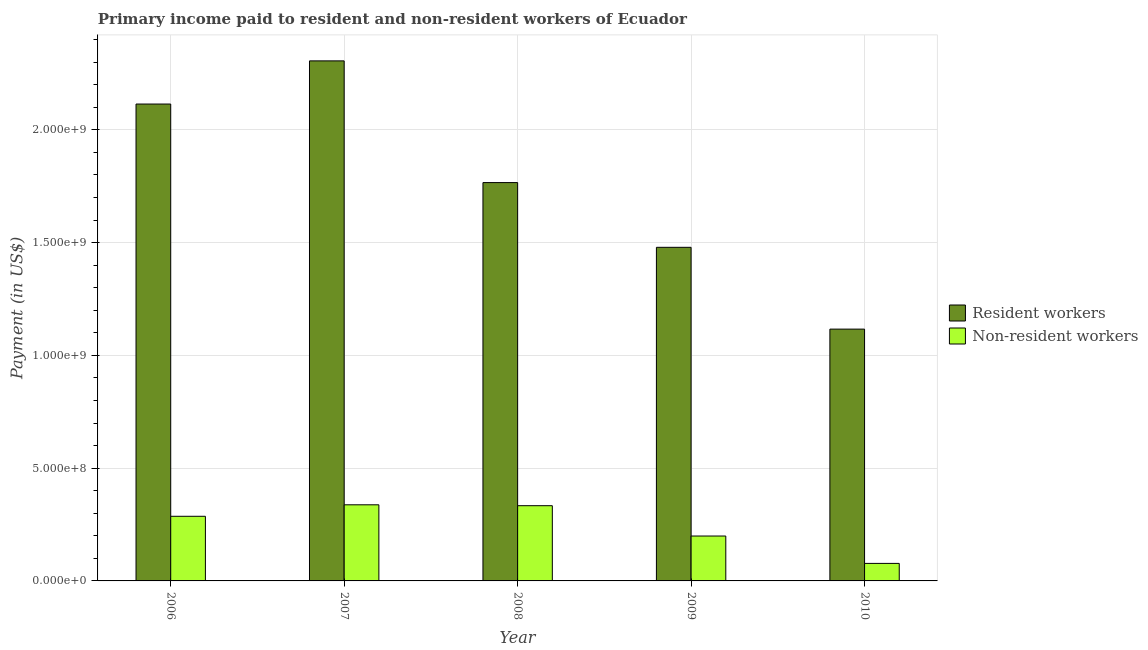How many bars are there on the 5th tick from the right?
Give a very brief answer. 2. What is the label of the 4th group of bars from the left?
Provide a short and direct response. 2009. In how many cases, is the number of bars for a given year not equal to the number of legend labels?
Give a very brief answer. 0. What is the payment made to non-resident workers in 2007?
Offer a very short reply. 3.37e+08. Across all years, what is the maximum payment made to non-resident workers?
Provide a short and direct response. 3.37e+08. Across all years, what is the minimum payment made to non-resident workers?
Keep it short and to the point. 7.77e+07. In which year was the payment made to non-resident workers maximum?
Keep it short and to the point. 2007. What is the total payment made to resident workers in the graph?
Give a very brief answer. 8.78e+09. What is the difference between the payment made to non-resident workers in 2008 and that in 2010?
Give a very brief answer. 2.56e+08. What is the difference between the payment made to resident workers in 2006 and the payment made to non-resident workers in 2007?
Ensure brevity in your answer.  -1.91e+08. What is the average payment made to non-resident workers per year?
Provide a succinct answer. 2.47e+08. In the year 2010, what is the difference between the payment made to resident workers and payment made to non-resident workers?
Your answer should be very brief. 0. In how many years, is the payment made to non-resident workers greater than 600000000 US$?
Keep it short and to the point. 0. What is the ratio of the payment made to non-resident workers in 2006 to that in 2010?
Your response must be concise. 3.69. What is the difference between the highest and the second highest payment made to non-resident workers?
Offer a terse response. 3.93e+06. What is the difference between the highest and the lowest payment made to non-resident workers?
Offer a terse response. 2.60e+08. In how many years, is the payment made to non-resident workers greater than the average payment made to non-resident workers taken over all years?
Offer a terse response. 3. What does the 2nd bar from the left in 2010 represents?
Give a very brief answer. Non-resident workers. What does the 1st bar from the right in 2008 represents?
Provide a succinct answer. Non-resident workers. How many bars are there?
Keep it short and to the point. 10. How many years are there in the graph?
Offer a terse response. 5. What is the difference between two consecutive major ticks on the Y-axis?
Offer a terse response. 5.00e+08. Does the graph contain any zero values?
Ensure brevity in your answer.  No. How are the legend labels stacked?
Provide a short and direct response. Vertical. What is the title of the graph?
Your response must be concise. Primary income paid to resident and non-resident workers of Ecuador. What is the label or title of the X-axis?
Make the answer very short. Year. What is the label or title of the Y-axis?
Provide a succinct answer. Payment (in US$). What is the Payment (in US$) of Resident workers in 2006?
Your answer should be compact. 2.11e+09. What is the Payment (in US$) in Non-resident workers in 2006?
Make the answer very short. 2.87e+08. What is the Payment (in US$) in Resident workers in 2007?
Provide a succinct answer. 2.31e+09. What is the Payment (in US$) in Non-resident workers in 2007?
Your answer should be compact. 3.37e+08. What is the Payment (in US$) in Resident workers in 2008?
Offer a terse response. 1.77e+09. What is the Payment (in US$) in Non-resident workers in 2008?
Your answer should be compact. 3.34e+08. What is the Payment (in US$) of Resident workers in 2009?
Offer a terse response. 1.48e+09. What is the Payment (in US$) of Non-resident workers in 2009?
Keep it short and to the point. 1.99e+08. What is the Payment (in US$) of Resident workers in 2010?
Ensure brevity in your answer.  1.12e+09. What is the Payment (in US$) in Non-resident workers in 2010?
Your answer should be very brief. 7.77e+07. Across all years, what is the maximum Payment (in US$) in Resident workers?
Provide a succinct answer. 2.31e+09. Across all years, what is the maximum Payment (in US$) of Non-resident workers?
Your answer should be compact. 3.37e+08. Across all years, what is the minimum Payment (in US$) in Resident workers?
Your response must be concise. 1.12e+09. Across all years, what is the minimum Payment (in US$) of Non-resident workers?
Your response must be concise. 7.77e+07. What is the total Payment (in US$) in Resident workers in the graph?
Provide a succinct answer. 8.78e+09. What is the total Payment (in US$) of Non-resident workers in the graph?
Provide a short and direct response. 1.23e+09. What is the difference between the Payment (in US$) of Resident workers in 2006 and that in 2007?
Give a very brief answer. -1.91e+08. What is the difference between the Payment (in US$) of Non-resident workers in 2006 and that in 2007?
Your answer should be very brief. -5.09e+07. What is the difference between the Payment (in US$) in Resident workers in 2006 and that in 2008?
Provide a short and direct response. 3.48e+08. What is the difference between the Payment (in US$) of Non-resident workers in 2006 and that in 2008?
Your answer should be compact. -4.69e+07. What is the difference between the Payment (in US$) of Resident workers in 2006 and that in 2009?
Offer a very short reply. 6.35e+08. What is the difference between the Payment (in US$) of Non-resident workers in 2006 and that in 2009?
Make the answer very short. 8.75e+07. What is the difference between the Payment (in US$) of Resident workers in 2006 and that in 2010?
Your answer should be compact. 9.98e+08. What is the difference between the Payment (in US$) of Non-resident workers in 2006 and that in 2010?
Your answer should be very brief. 2.09e+08. What is the difference between the Payment (in US$) in Resident workers in 2007 and that in 2008?
Offer a very short reply. 5.40e+08. What is the difference between the Payment (in US$) of Non-resident workers in 2007 and that in 2008?
Your response must be concise. 3.93e+06. What is the difference between the Payment (in US$) in Resident workers in 2007 and that in 2009?
Your response must be concise. 8.27e+08. What is the difference between the Payment (in US$) in Non-resident workers in 2007 and that in 2009?
Your response must be concise. 1.38e+08. What is the difference between the Payment (in US$) in Resident workers in 2007 and that in 2010?
Your answer should be very brief. 1.19e+09. What is the difference between the Payment (in US$) in Non-resident workers in 2007 and that in 2010?
Provide a succinct answer. 2.60e+08. What is the difference between the Payment (in US$) in Resident workers in 2008 and that in 2009?
Ensure brevity in your answer.  2.87e+08. What is the difference between the Payment (in US$) in Non-resident workers in 2008 and that in 2009?
Your answer should be compact. 1.34e+08. What is the difference between the Payment (in US$) of Resident workers in 2008 and that in 2010?
Provide a short and direct response. 6.50e+08. What is the difference between the Payment (in US$) of Non-resident workers in 2008 and that in 2010?
Provide a succinct answer. 2.56e+08. What is the difference between the Payment (in US$) of Resident workers in 2009 and that in 2010?
Offer a terse response. 3.63e+08. What is the difference between the Payment (in US$) of Non-resident workers in 2009 and that in 2010?
Provide a short and direct response. 1.21e+08. What is the difference between the Payment (in US$) of Resident workers in 2006 and the Payment (in US$) of Non-resident workers in 2007?
Give a very brief answer. 1.78e+09. What is the difference between the Payment (in US$) in Resident workers in 2006 and the Payment (in US$) in Non-resident workers in 2008?
Keep it short and to the point. 1.78e+09. What is the difference between the Payment (in US$) in Resident workers in 2006 and the Payment (in US$) in Non-resident workers in 2009?
Your response must be concise. 1.92e+09. What is the difference between the Payment (in US$) of Resident workers in 2006 and the Payment (in US$) of Non-resident workers in 2010?
Offer a very short reply. 2.04e+09. What is the difference between the Payment (in US$) in Resident workers in 2007 and the Payment (in US$) in Non-resident workers in 2008?
Your answer should be compact. 1.97e+09. What is the difference between the Payment (in US$) in Resident workers in 2007 and the Payment (in US$) in Non-resident workers in 2009?
Your answer should be compact. 2.11e+09. What is the difference between the Payment (in US$) of Resident workers in 2007 and the Payment (in US$) of Non-resident workers in 2010?
Make the answer very short. 2.23e+09. What is the difference between the Payment (in US$) in Resident workers in 2008 and the Payment (in US$) in Non-resident workers in 2009?
Ensure brevity in your answer.  1.57e+09. What is the difference between the Payment (in US$) of Resident workers in 2008 and the Payment (in US$) of Non-resident workers in 2010?
Keep it short and to the point. 1.69e+09. What is the difference between the Payment (in US$) in Resident workers in 2009 and the Payment (in US$) in Non-resident workers in 2010?
Provide a short and direct response. 1.40e+09. What is the average Payment (in US$) in Resident workers per year?
Offer a very short reply. 1.76e+09. What is the average Payment (in US$) of Non-resident workers per year?
Your answer should be compact. 2.47e+08. In the year 2006, what is the difference between the Payment (in US$) in Resident workers and Payment (in US$) in Non-resident workers?
Your answer should be very brief. 1.83e+09. In the year 2007, what is the difference between the Payment (in US$) in Resident workers and Payment (in US$) in Non-resident workers?
Your response must be concise. 1.97e+09. In the year 2008, what is the difference between the Payment (in US$) in Resident workers and Payment (in US$) in Non-resident workers?
Provide a succinct answer. 1.43e+09. In the year 2009, what is the difference between the Payment (in US$) of Resident workers and Payment (in US$) of Non-resident workers?
Your answer should be compact. 1.28e+09. In the year 2010, what is the difference between the Payment (in US$) of Resident workers and Payment (in US$) of Non-resident workers?
Provide a short and direct response. 1.04e+09. What is the ratio of the Payment (in US$) of Resident workers in 2006 to that in 2007?
Offer a terse response. 0.92. What is the ratio of the Payment (in US$) in Non-resident workers in 2006 to that in 2007?
Provide a succinct answer. 0.85. What is the ratio of the Payment (in US$) of Resident workers in 2006 to that in 2008?
Offer a terse response. 1.2. What is the ratio of the Payment (in US$) in Non-resident workers in 2006 to that in 2008?
Your answer should be compact. 0.86. What is the ratio of the Payment (in US$) in Resident workers in 2006 to that in 2009?
Offer a terse response. 1.43. What is the ratio of the Payment (in US$) of Non-resident workers in 2006 to that in 2009?
Make the answer very short. 1.44. What is the ratio of the Payment (in US$) in Resident workers in 2006 to that in 2010?
Your answer should be compact. 1.89. What is the ratio of the Payment (in US$) in Non-resident workers in 2006 to that in 2010?
Provide a short and direct response. 3.69. What is the ratio of the Payment (in US$) of Resident workers in 2007 to that in 2008?
Provide a succinct answer. 1.31. What is the ratio of the Payment (in US$) in Non-resident workers in 2007 to that in 2008?
Make the answer very short. 1.01. What is the ratio of the Payment (in US$) in Resident workers in 2007 to that in 2009?
Provide a short and direct response. 1.56. What is the ratio of the Payment (in US$) of Non-resident workers in 2007 to that in 2009?
Give a very brief answer. 1.7. What is the ratio of the Payment (in US$) of Resident workers in 2007 to that in 2010?
Provide a short and direct response. 2.07. What is the ratio of the Payment (in US$) in Non-resident workers in 2007 to that in 2010?
Provide a succinct answer. 4.34. What is the ratio of the Payment (in US$) of Resident workers in 2008 to that in 2009?
Offer a very short reply. 1.19. What is the ratio of the Payment (in US$) in Non-resident workers in 2008 to that in 2009?
Provide a short and direct response. 1.68. What is the ratio of the Payment (in US$) of Resident workers in 2008 to that in 2010?
Offer a terse response. 1.58. What is the ratio of the Payment (in US$) of Non-resident workers in 2008 to that in 2010?
Offer a terse response. 4.29. What is the ratio of the Payment (in US$) of Resident workers in 2009 to that in 2010?
Offer a very short reply. 1.32. What is the ratio of the Payment (in US$) in Non-resident workers in 2009 to that in 2010?
Keep it short and to the point. 2.56. What is the difference between the highest and the second highest Payment (in US$) of Resident workers?
Give a very brief answer. 1.91e+08. What is the difference between the highest and the second highest Payment (in US$) in Non-resident workers?
Give a very brief answer. 3.93e+06. What is the difference between the highest and the lowest Payment (in US$) of Resident workers?
Ensure brevity in your answer.  1.19e+09. What is the difference between the highest and the lowest Payment (in US$) of Non-resident workers?
Make the answer very short. 2.60e+08. 